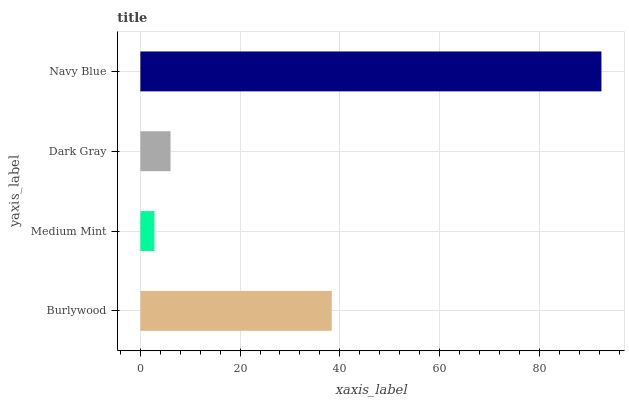Is Medium Mint the minimum?
Answer yes or no. Yes. Is Navy Blue the maximum?
Answer yes or no. Yes. Is Dark Gray the minimum?
Answer yes or no. No. Is Dark Gray the maximum?
Answer yes or no. No. Is Dark Gray greater than Medium Mint?
Answer yes or no. Yes. Is Medium Mint less than Dark Gray?
Answer yes or no. Yes. Is Medium Mint greater than Dark Gray?
Answer yes or no. No. Is Dark Gray less than Medium Mint?
Answer yes or no. No. Is Burlywood the high median?
Answer yes or no. Yes. Is Dark Gray the low median?
Answer yes or no. Yes. Is Navy Blue the high median?
Answer yes or no. No. Is Medium Mint the low median?
Answer yes or no. No. 